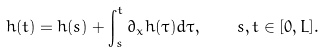<formula> <loc_0><loc_0><loc_500><loc_500>h ( t ) = h ( s ) + \int _ { s } ^ { t } \partial _ { x } h ( \tau ) d \tau , \quad s , t \in [ 0 , L ] .</formula> 